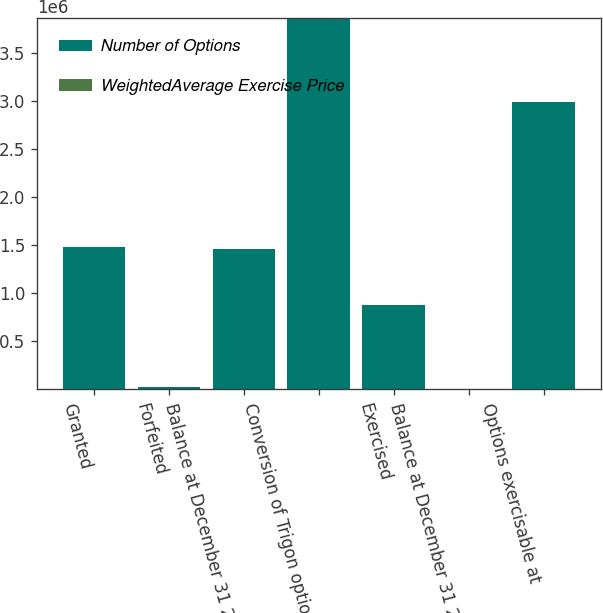Convert chart. <chart><loc_0><loc_0><loc_500><loc_500><stacked_bar_chart><ecel><fcel>Granted<fcel>Forfeited<fcel>Balance at December 31 2001<fcel>Conversion of Trigon options<fcel>Exercised<fcel>Balance at December 31 2002<fcel>Options exercisable at<nl><fcel>Number of Options<fcel>1.479e+06<fcel>20368<fcel>1.45863e+06<fcel>3.86677e+06<fcel>877959<fcel>36<fcel>2.9929e+06<nl><fcel>WeightedAverage Exercise Price<fcel>36<fcel>36<fcel>36<fcel>30.86<fcel>27.36<fcel>43.48<fcel>31.9<nl></chart> 